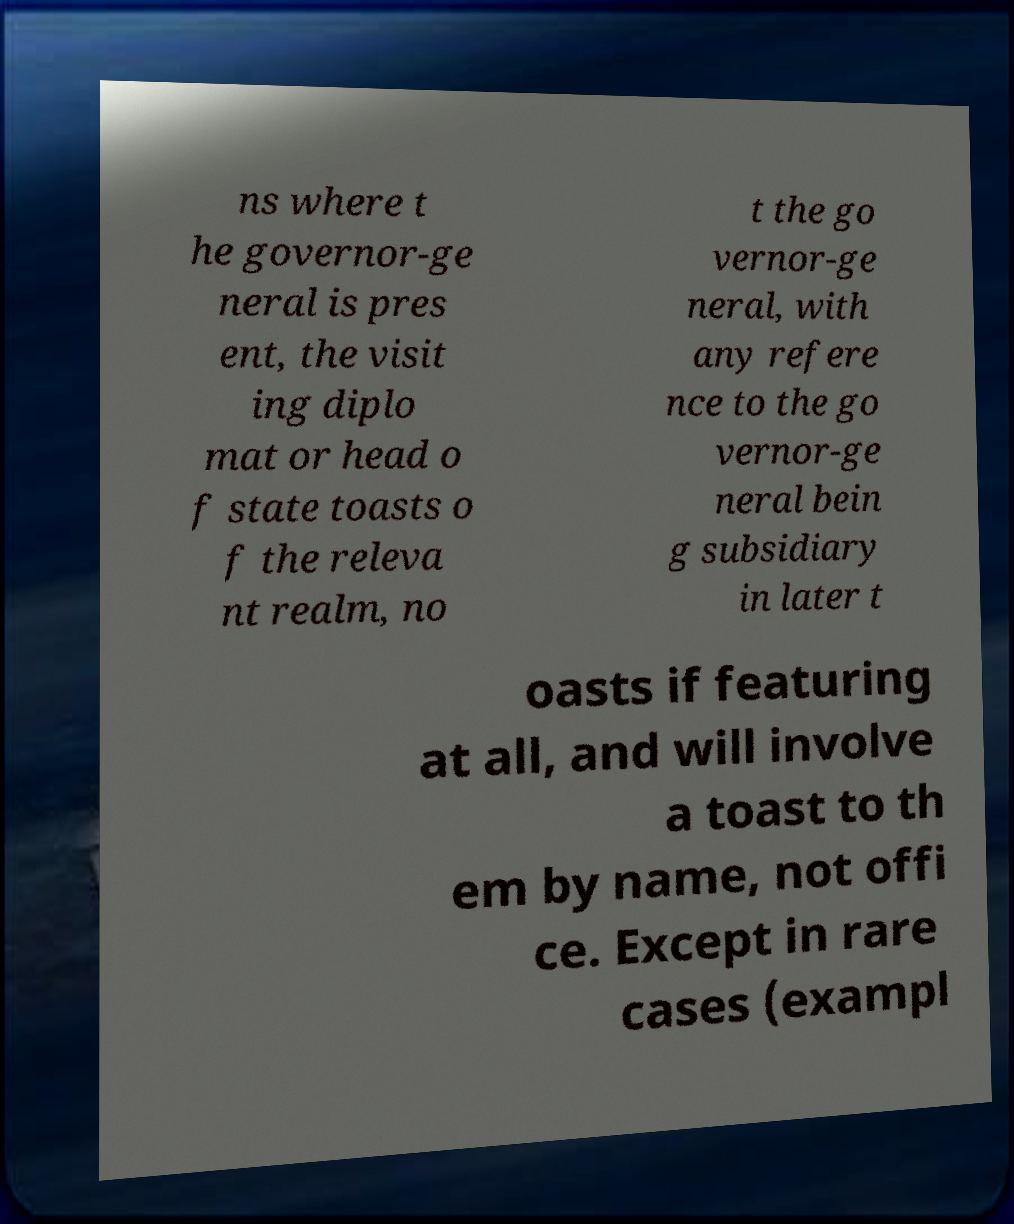I need the written content from this picture converted into text. Can you do that? ns where t he governor-ge neral is pres ent, the visit ing diplo mat or head o f state toasts o f the releva nt realm, no t the go vernor-ge neral, with any refere nce to the go vernor-ge neral bein g subsidiary in later t oasts if featuring at all, and will involve a toast to th em by name, not offi ce. Except in rare cases (exampl 